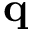Convert formula to latex. <formula><loc_0><loc_0><loc_500><loc_500>{ q }</formula> 